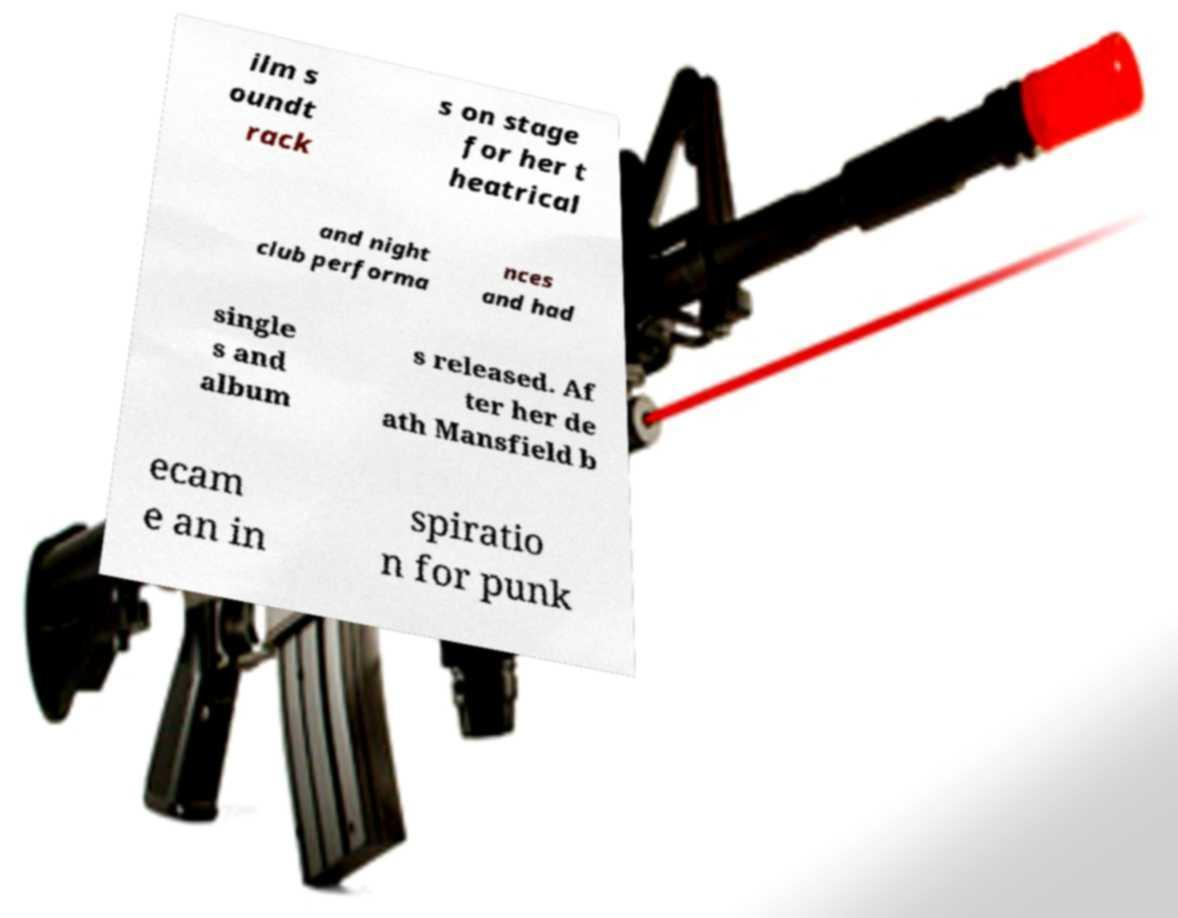Could you assist in decoding the text presented in this image and type it out clearly? ilm s oundt rack s on stage for her t heatrical and night club performa nces and had single s and album s released. Af ter her de ath Mansfield b ecam e an in spiratio n for punk 